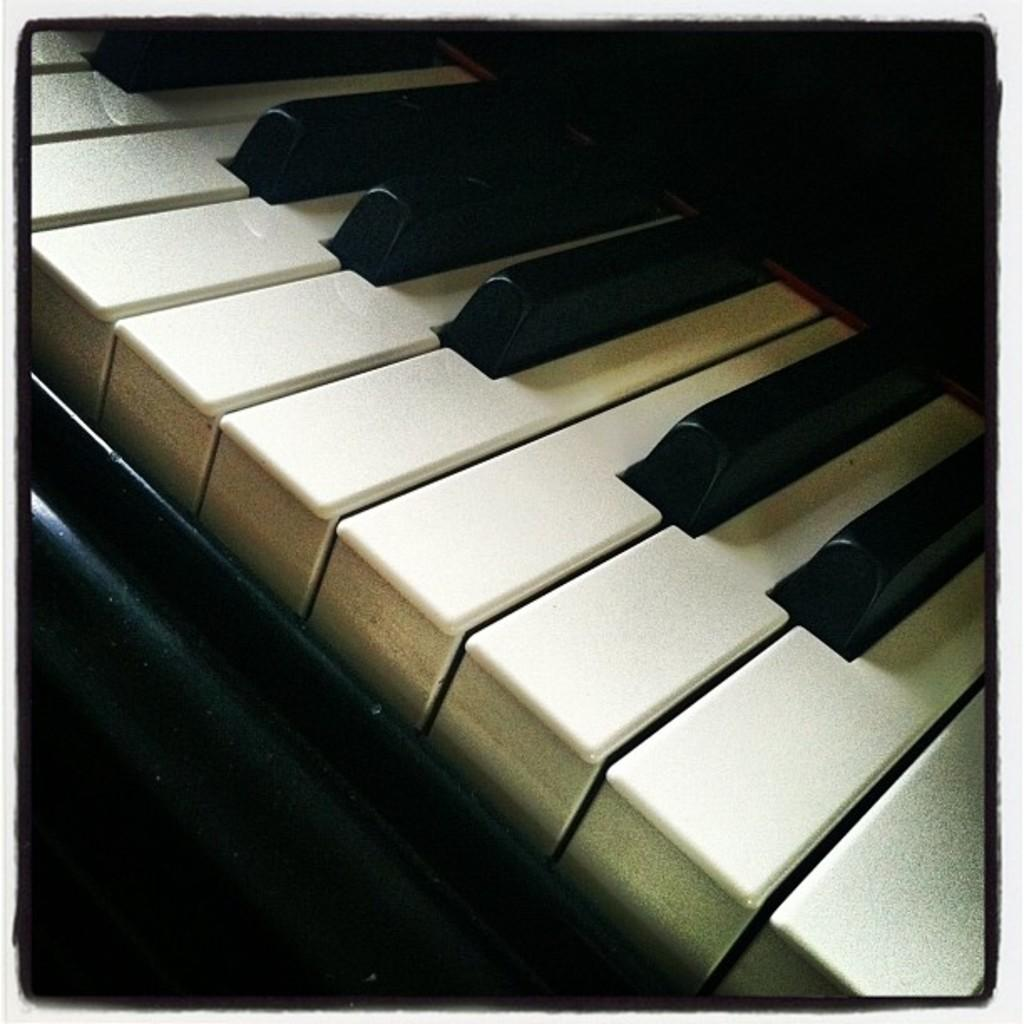What musical instrument is featured in the image? There is a piano keyboard in the image. What can be observed about the keys on the piano keyboard? The piano keyboard has black and white colored keys. What type of vest is the piano wearing in the image? The piano is not a living being and therefore cannot wear a vest. The image features a piano keyboard, not a complete piano. 